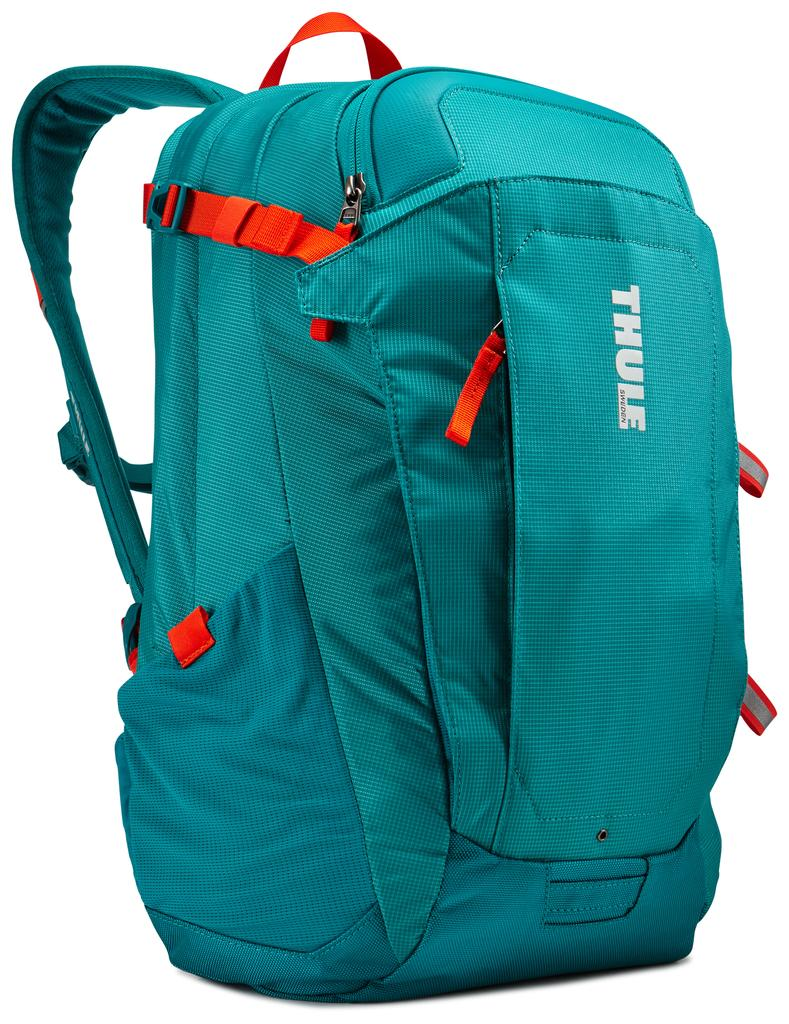<image>
Render a clear and concise summary of the photo. An aqua blue backpack made by Thule Sweden 